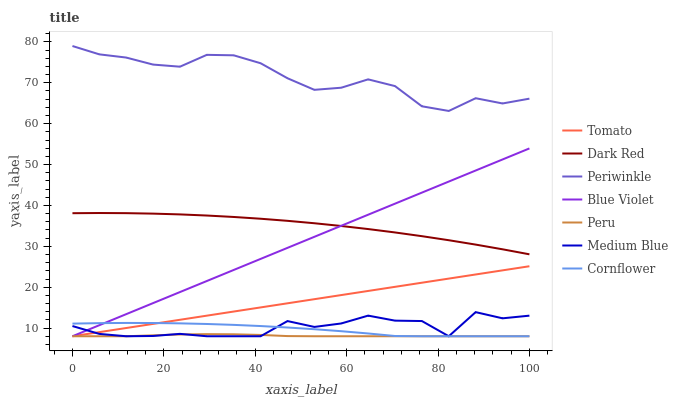Does Peru have the minimum area under the curve?
Answer yes or no. Yes. Does Periwinkle have the maximum area under the curve?
Answer yes or no. Yes. Does Cornflower have the minimum area under the curve?
Answer yes or no. No. Does Cornflower have the maximum area under the curve?
Answer yes or no. No. Is Tomato the smoothest?
Answer yes or no. Yes. Is Medium Blue the roughest?
Answer yes or no. Yes. Is Cornflower the smoothest?
Answer yes or no. No. Is Cornflower the roughest?
Answer yes or no. No. Does Tomato have the lowest value?
Answer yes or no. Yes. Does Dark Red have the lowest value?
Answer yes or no. No. Does Periwinkle have the highest value?
Answer yes or no. Yes. Does Cornflower have the highest value?
Answer yes or no. No. Is Tomato less than Dark Red?
Answer yes or no. Yes. Is Periwinkle greater than Blue Violet?
Answer yes or no. Yes. Does Tomato intersect Medium Blue?
Answer yes or no. Yes. Is Tomato less than Medium Blue?
Answer yes or no. No. Is Tomato greater than Medium Blue?
Answer yes or no. No. Does Tomato intersect Dark Red?
Answer yes or no. No. 